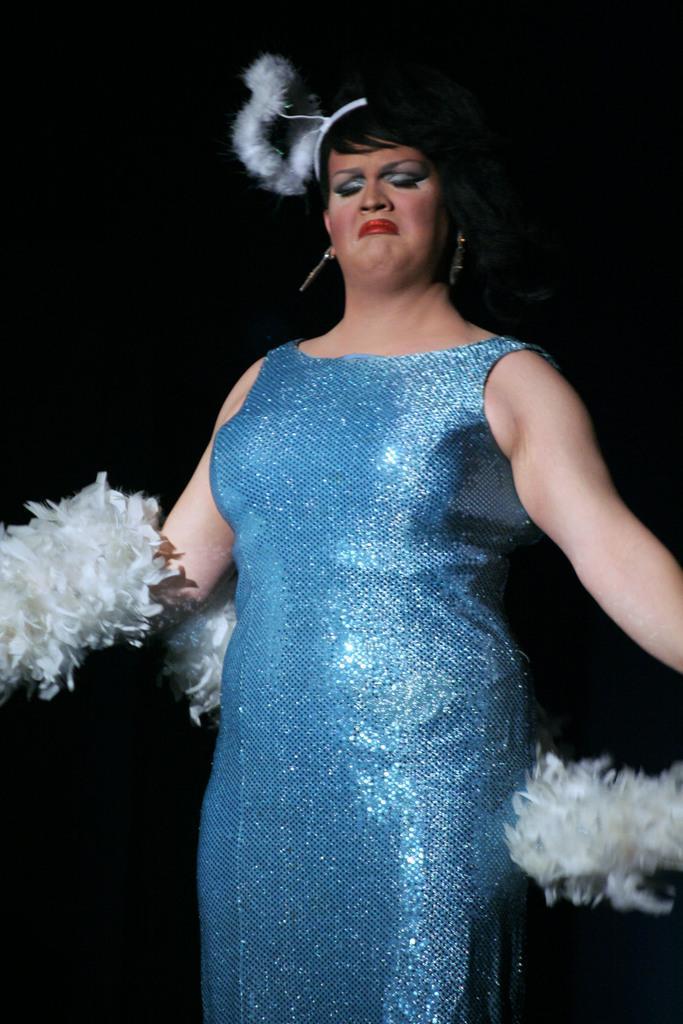Could you give a brief overview of what you see in this image? In the picture we can see a woman standing a blue dress and holding something in the hand and dancing and behind her we can see dark. 